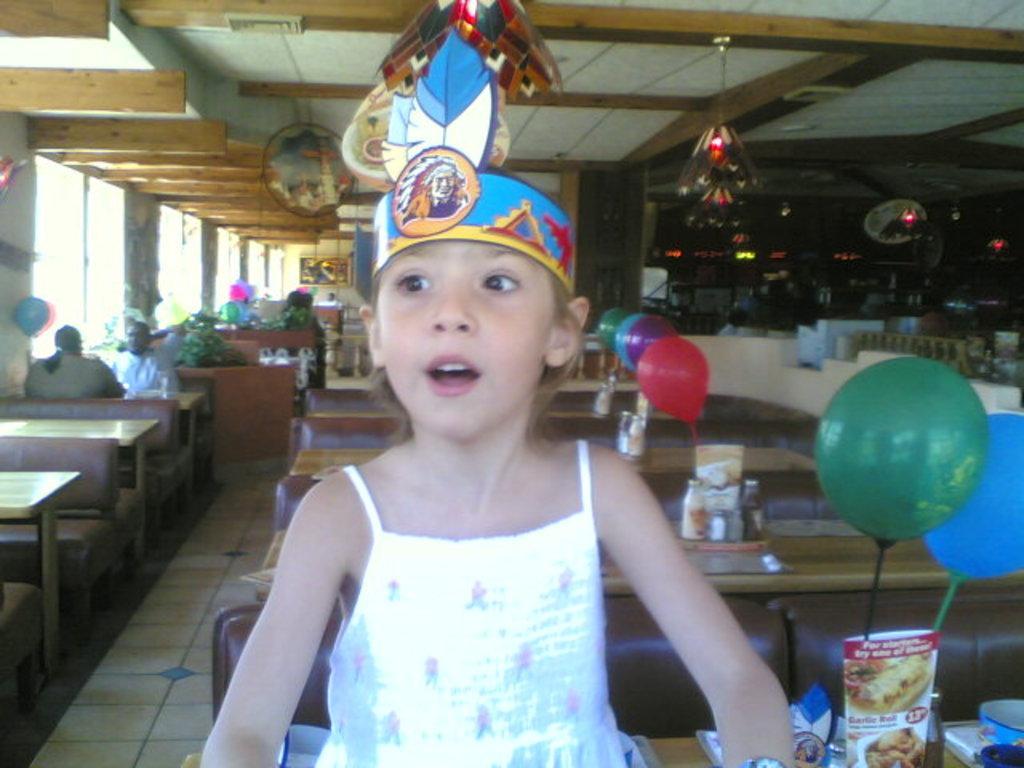How would you summarize this image in a sentence or two? The picture consists of tables, balloons, food items, people, plants and various other objects. The picture might be taken inside a restaurant. On the left we can see windows. On the right there are couches and decorative items. At the top there is ceiling. 